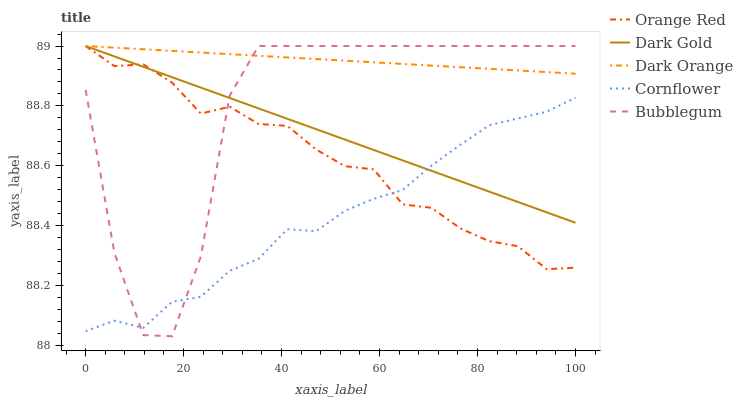Does Cornflower have the minimum area under the curve?
Answer yes or no. Yes. Does Dark Orange have the maximum area under the curve?
Answer yes or no. Yes. Does Orange Red have the minimum area under the curve?
Answer yes or no. No. Does Orange Red have the maximum area under the curve?
Answer yes or no. No. Is Dark Gold the smoothest?
Answer yes or no. Yes. Is Bubblegum the roughest?
Answer yes or no. Yes. Is Cornflower the smoothest?
Answer yes or no. No. Is Cornflower the roughest?
Answer yes or no. No. Does Cornflower have the lowest value?
Answer yes or no. No. Does Cornflower have the highest value?
Answer yes or no. No. Is Cornflower less than Dark Orange?
Answer yes or no. Yes. Is Dark Orange greater than Cornflower?
Answer yes or no. Yes. Does Cornflower intersect Dark Orange?
Answer yes or no. No. 